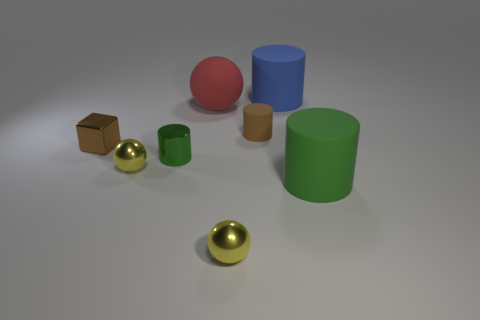There is a tiny brown thing that is to the right of the brown metal cube; is it the same shape as the brown shiny thing?
Keep it short and to the point. No. The green object that is left of the small thing that is on the right side of the yellow shiny thing to the right of the green metallic thing is what shape?
Offer a terse response. Cylinder. What is the shape of the metallic object that is the same color as the small matte cylinder?
Your response must be concise. Cube. There is a small object that is behind the tiny metal cylinder and to the right of the tiny green thing; what material is it?
Keep it short and to the point. Rubber. Are there fewer blue objects than green metallic blocks?
Give a very brief answer. No. There is a tiny rubber thing; does it have the same shape as the big matte thing that is on the right side of the large blue matte cylinder?
Your answer should be compact. Yes. There is a metal sphere that is in front of the green matte cylinder; does it have the same size as the tiny metal cube?
Keep it short and to the point. Yes. There is another brown thing that is the same size as the brown metal thing; what shape is it?
Keep it short and to the point. Cylinder. Does the green rubber object have the same shape as the small brown matte thing?
Your answer should be very brief. Yes. What number of yellow things are the same shape as the large red matte thing?
Your answer should be compact. 2. 